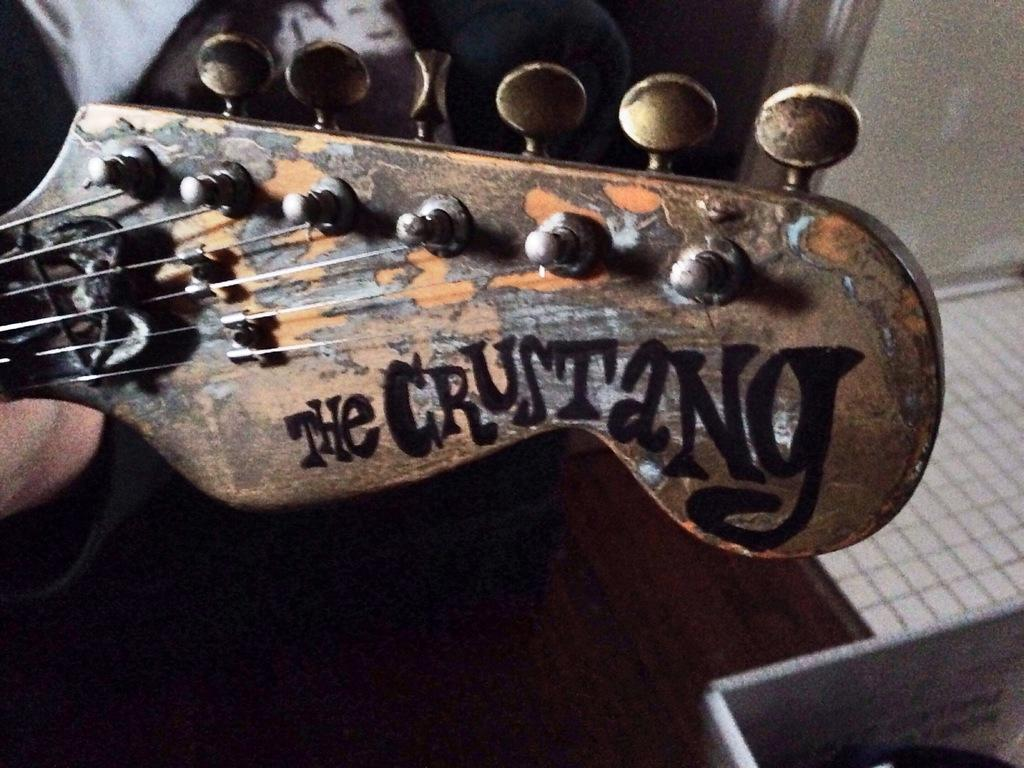What is the main object in the picture? There is a guitar in the picture. What feature of the guitar is mentioned in the facts? The guitar has strings. What type of brass instrument is being played in the picture? There is no brass instrument present in the picture; it features a guitar. What sheet music is being used to play the guitar in the picture? There is no sheet music visible in the picture, and the guitar is not being played. 